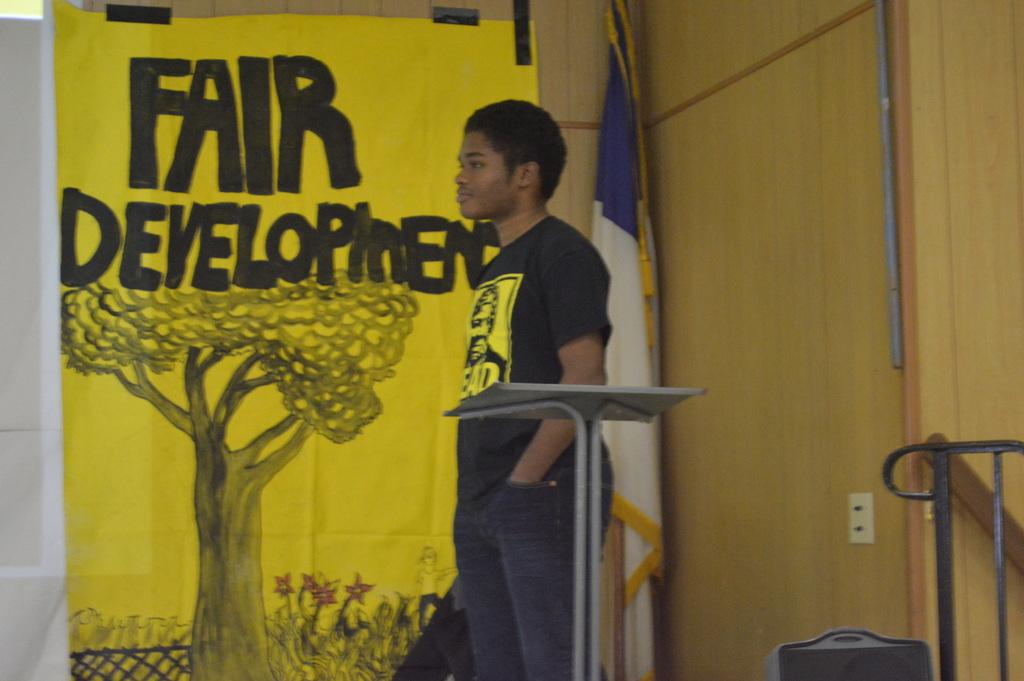Who is the main subject in the image? There is a boy in the center of the image. What is in front of the boy? There is a desk in front of the boy. What can be seen in the background of the image? There is a poster and a flag in the background of the image. What type of farm animals can be seen in the image? There are no farm animals present in the image. How does the boy participate in the fight in the image? There is no fight or any indication of fighting in the image. 